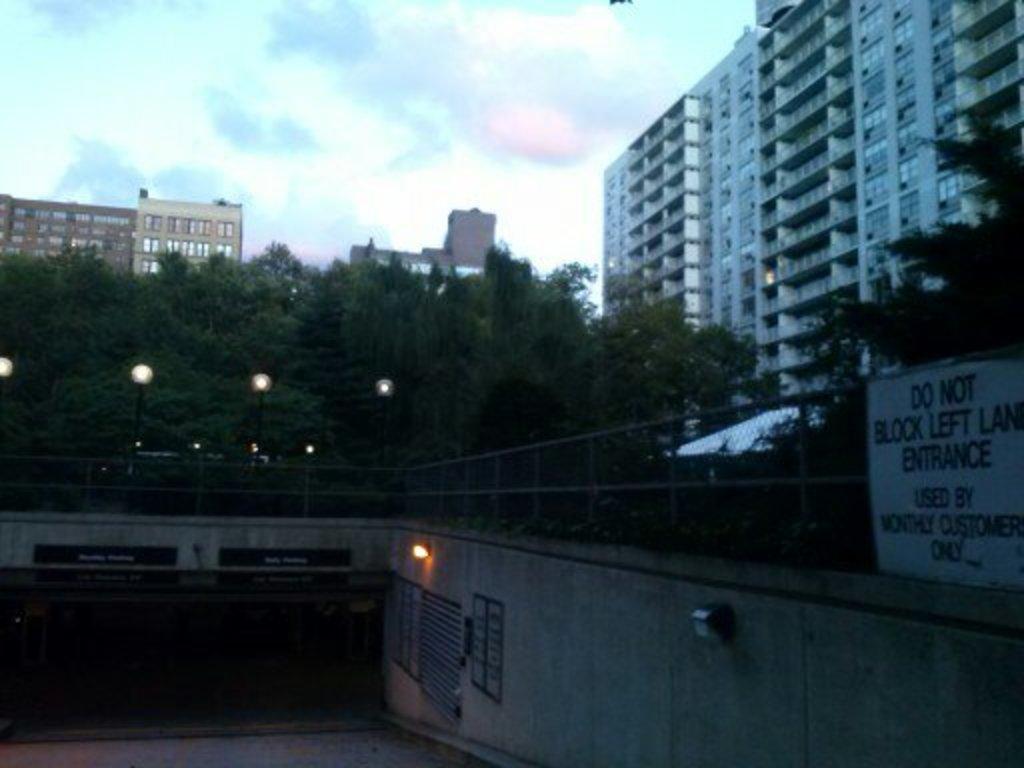Please provide a concise description of this image. In this image, there are a few buildings, trees, poles with lights. We can see the wall with some objects. We can see the ground and the sky with clouds. We can see a board with some text on the right. We can also see a white colored object. 